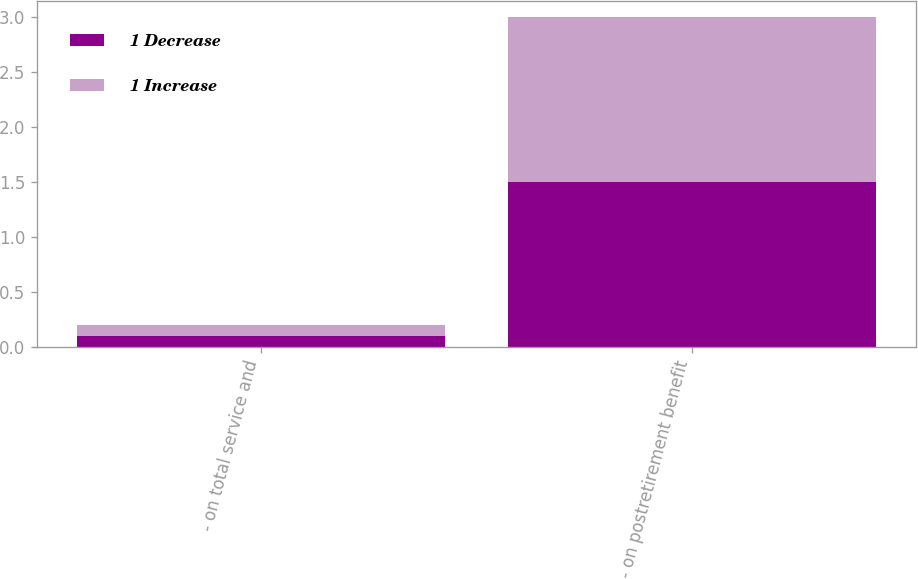Convert chart. <chart><loc_0><loc_0><loc_500><loc_500><stacked_bar_chart><ecel><fcel>- on total service and<fcel>- on postretirement benefit<nl><fcel>1 Decrease<fcel>0.1<fcel>1.5<nl><fcel>1 Increase<fcel>0.1<fcel>1.5<nl></chart> 